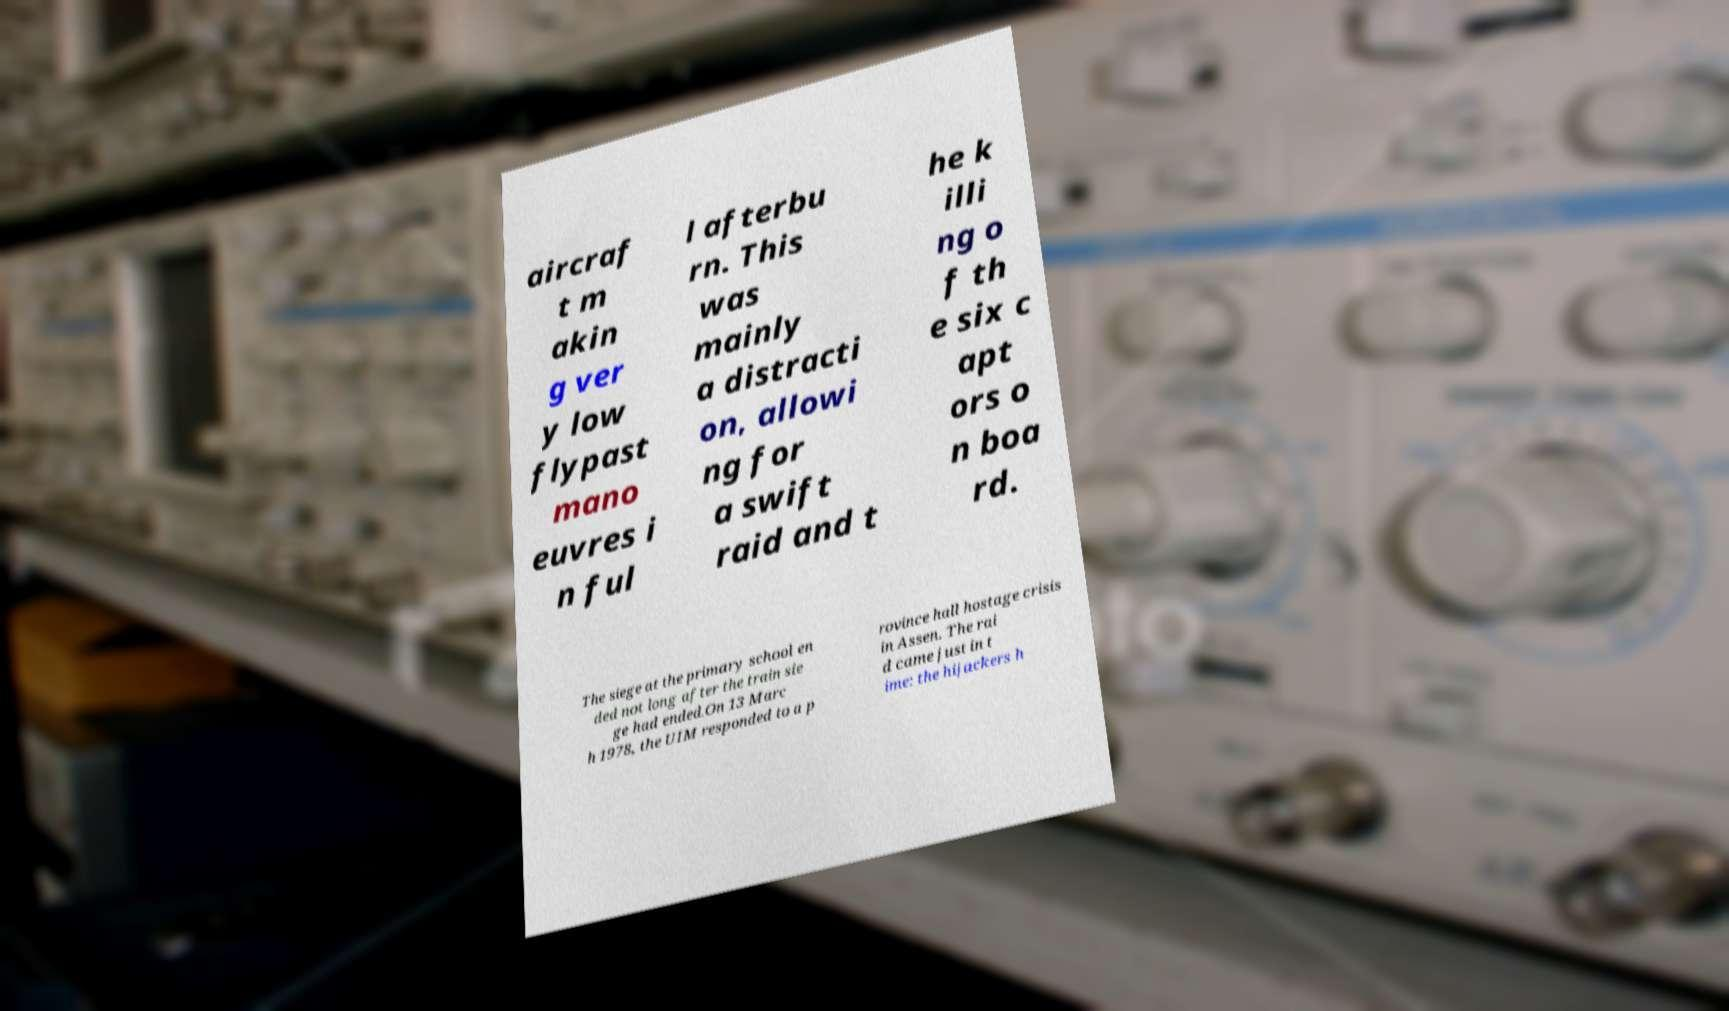What messages or text are displayed in this image? I need them in a readable, typed format. aircraf t m akin g ver y low flypast mano euvres i n ful l afterbu rn. This was mainly a distracti on, allowi ng for a swift raid and t he k illi ng o f th e six c apt ors o n boa rd. The siege at the primary school en ded not long after the train sie ge had ended.On 13 Marc h 1978, the UIM responded to a p rovince hall hostage crisis in Assen. The rai d came just in t ime: the hijackers h 